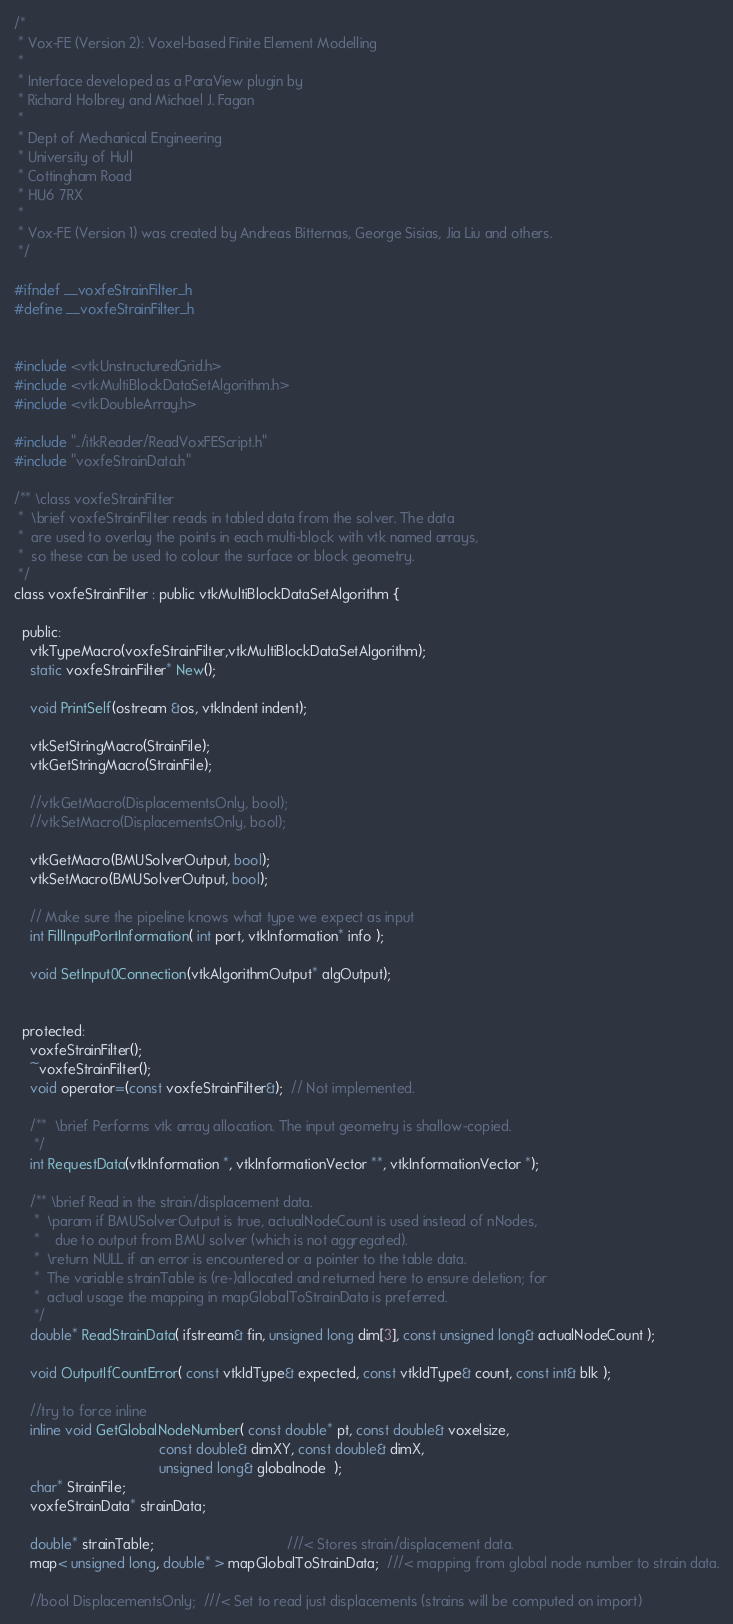Convert code to text. <code><loc_0><loc_0><loc_500><loc_500><_C_>/*
 * Vox-FE (Version 2): Voxel-based Finite Element Modelling
 *
 * Interface developed as a ParaView plugin by
 * Richard Holbrey and Michael J. Fagan
 *
 * Dept of Mechanical Engineering
 * University of Hull
 * Cottingham Road
 * HU6 7RX
 *
 * Vox-FE (Version 1) was created by Andreas Bitternas, George Sisias, Jia Liu and others.
 */

#ifndef __voxfeStrainFilter_h
#define __voxfeStrainFilter_h


#include <vtkUnstructuredGrid.h>
#include <vtkMultiBlockDataSetAlgorithm.h>
#include <vtkDoubleArray.h>

#include "../itkReader/ReadVoxFEScript.h"
#include "voxfeStrainData.h"

/** \class voxfeStrainFilter
 *  \brief voxfeStrainFilter reads in tabled data from the solver. The data
 *  are used to overlay the points in each multi-block with vtk named arrays,
 *  so these can be used to colour the surface or block geometry.
 */
class voxfeStrainFilter : public vtkMultiBlockDataSetAlgorithm { 

  public:
    vtkTypeMacro(voxfeStrainFilter,vtkMultiBlockDataSetAlgorithm);
    static voxfeStrainFilter* New();
    
    void PrintSelf(ostream &os, vtkIndent indent);

    vtkSetStringMacro(StrainFile);
    vtkGetStringMacro(StrainFile);

    //vtkGetMacro(DisplacementsOnly, bool);
    //vtkSetMacro(DisplacementsOnly, bool);

    vtkGetMacro(BMUSolverOutput, bool);
    vtkSetMacro(BMUSolverOutput, bool);

    // Make sure the pipeline knows what type we expect as input
    int FillInputPortInformation( int port, vtkInformation* info );
    
    void SetInput0Connection(vtkAlgorithmOutput* algOutput);


  protected:
    voxfeStrainFilter();
    ~voxfeStrainFilter();
    void operator=(const voxfeStrainFilter&);  // Not implemented.
 
    /**  \brief Performs vtk array allocation. The input geometry is shallow-copied.
     */
    int RequestData(vtkInformation *, vtkInformationVector **, vtkInformationVector *);

    /** \brief Read in the strain/displacement data.
     *  \param if BMUSolverOutput is true, actualNodeCount is used instead of nNodes,
     *    due to output from BMU solver (which is not aggregated).
     *  \return NULL if an error is encountered or a pointer to the table data.
     *  The variable strainTable is (re-)allocated and returned here to ensure deletion; for
     *  actual usage the mapping in mapGlobalToStrainData is preferred.
     */
    double* ReadStrainData( ifstream& fin, unsigned long dim[3], const unsigned long& actualNodeCount );

    void OutputIfCountError( const vtkIdType& expected, const vtkIdType& count, const int& blk );

    //try to force inline
    inline void GetGlobalNodeNumber( const double* pt, const double& voxelsize,
                                     const double& dimXY, const double& dimX,
                                     unsigned long& globalnode  );
    char* StrainFile;
    voxfeStrainData* strainData;
    
    double* strainTable;                                  ///< Stores strain/displacement data.
    map< unsigned long, double* > mapGlobalToStrainData;  ///< mapping from global node number to strain data.

    //bool DisplacementsOnly;  ///< Set to read just displacements (strains will be computed on import)</code> 